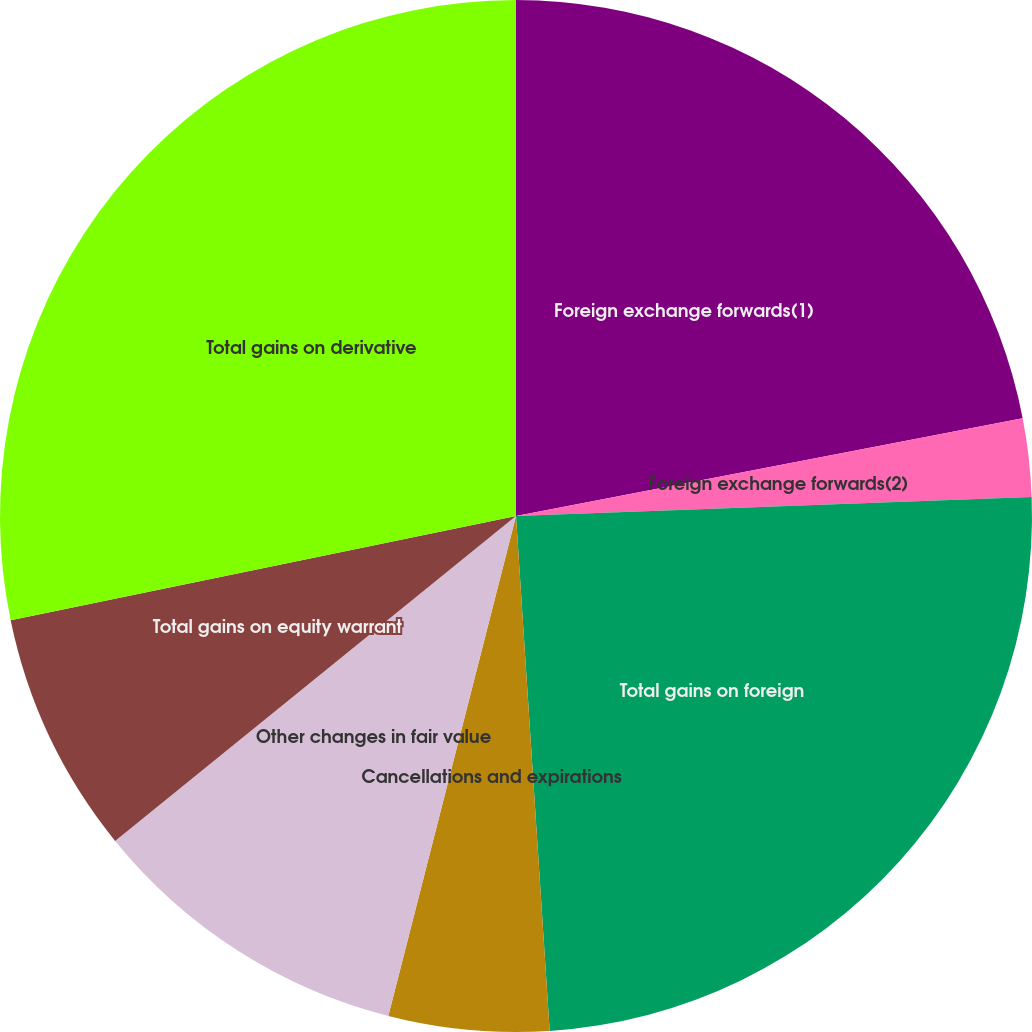Convert chart. <chart><loc_0><loc_0><loc_500><loc_500><pie_chart><fcel>Foreign exchange forwards(1)<fcel>Foreign exchange forwards(2)<fcel>Total gains on foreign<fcel>Cancellations and expirations<fcel>Other changes in fair value<fcel>Total gains on equity warrant<fcel>Total gains on derivative<nl><fcel>21.97%<fcel>2.44%<fcel>24.55%<fcel>5.02%<fcel>10.18%<fcel>7.6%<fcel>28.24%<nl></chart> 